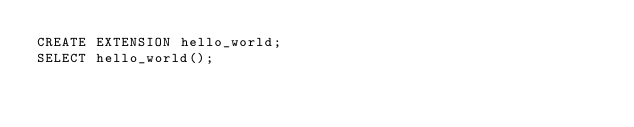<code> <loc_0><loc_0><loc_500><loc_500><_SQL_>CREATE EXTENSION hello_world;
SELECT hello_world();
</code> 